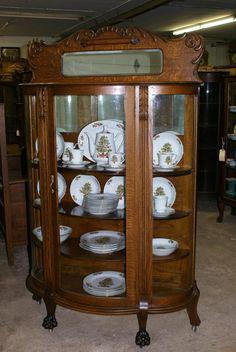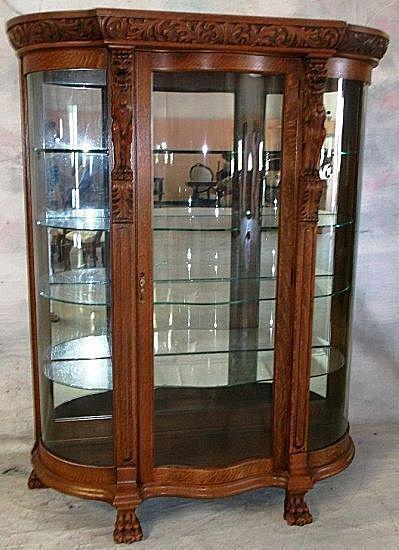The first image is the image on the left, the second image is the image on the right. Analyze the images presented: Is the assertion "One hutch has a horizontal spindle between the front legs, below a full-width drawer." valid? Answer yes or no. No. 